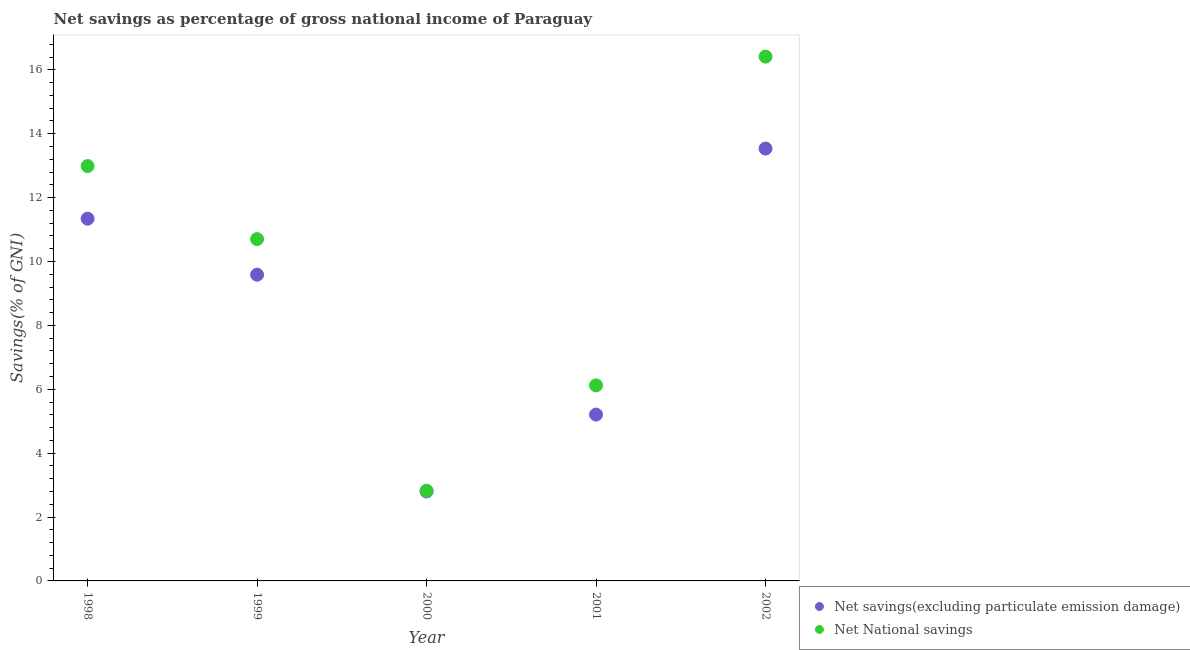How many different coloured dotlines are there?
Offer a terse response. 2. Is the number of dotlines equal to the number of legend labels?
Provide a succinct answer. Yes. What is the net national savings in 2000?
Offer a very short reply. 2.82. Across all years, what is the maximum net savings(excluding particulate emission damage)?
Your answer should be compact. 13.53. Across all years, what is the minimum net savings(excluding particulate emission damage)?
Your response must be concise. 2.8. In which year was the net national savings minimum?
Offer a very short reply. 2000. What is the total net national savings in the graph?
Make the answer very short. 49.04. What is the difference between the net national savings in 1999 and that in 2001?
Provide a short and direct response. 4.58. What is the difference between the net national savings in 1999 and the net savings(excluding particulate emission damage) in 2000?
Make the answer very short. 7.9. What is the average net savings(excluding particulate emission damage) per year?
Provide a succinct answer. 8.49. In the year 2001, what is the difference between the net national savings and net savings(excluding particulate emission damage)?
Ensure brevity in your answer.  0.91. In how many years, is the net national savings greater than 16.4 %?
Provide a succinct answer. 1. What is the ratio of the net savings(excluding particulate emission damage) in 1999 to that in 2001?
Your answer should be very brief. 1.84. What is the difference between the highest and the second highest net savings(excluding particulate emission damage)?
Your answer should be very brief. 2.19. What is the difference between the highest and the lowest net savings(excluding particulate emission damage)?
Provide a short and direct response. 10.73. In how many years, is the net savings(excluding particulate emission damage) greater than the average net savings(excluding particulate emission damage) taken over all years?
Keep it short and to the point. 3. Is the sum of the net national savings in 2000 and 2001 greater than the maximum net savings(excluding particulate emission damage) across all years?
Provide a succinct answer. No. Is the net savings(excluding particulate emission damage) strictly less than the net national savings over the years?
Your answer should be very brief. Yes. How many dotlines are there?
Offer a very short reply. 2. How many years are there in the graph?
Your answer should be very brief. 5. Does the graph contain any zero values?
Keep it short and to the point. No. How are the legend labels stacked?
Offer a terse response. Vertical. What is the title of the graph?
Provide a succinct answer. Net savings as percentage of gross national income of Paraguay. Does "Methane" appear as one of the legend labels in the graph?
Keep it short and to the point. No. What is the label or title of the Y-axis?
Your response must be concise. Savings(% of GNI). What is the Savings(% of GNI) of Net savings(excluding particulate emission damage) in 1998?
Offer a very short reply. 11.34. What is the Savings(% of GNI) of Net National savings in 1998?
Your answer should be very brief. 12.99. What is the Savings(% of GNI) of Net savings(excluding particulate emission damage) in 1999?
Your answer should be very brief. 9.59. What is the Savings(% of GNI) in Net National savings in 1999?
Keep it short and to the point. 10.7. What is the Savings(% of GNI) in Net savings(excluding particulate emission damage) in 2000?
Keep it short and to the point. 2.8. What is the Savings(% of GNI) in Net National savings in 2000?
Offer a very short reply. 2.82. What is the Savings(% of GNI) of Net savings(excluding particulate emission damage) in 2001?
Offer a terse response. 5.21. What is the Savings(% of GNI) of Net National savings in 2001?
Your answer should be very brief. 6.12. What is the Savings(% of GNI) of Net savings(excluding particulate emission damage) in 2002?
Offer a very short reply. 13.53. What is the Savings(% of GNI) of Net National savings in 2002?
Provide a succinct answer. 16.41. Across all years, what is the maximum Savings(% of GNI) of Net savings(excluding particulate emission damage)?
Keep it short and to the point. 13.53. Across all years, what is the maximum Savings(% of GNI) of Net National savings?
Provide a short and direct response. 16.41. Across all years, what is the minimum Savings(% of GNI) of Net savings(excluding particulate emission damage)?
Your response must be concise. 2.8. Across all years, what is the minimum Savings(% of GNI) in Net National savings?
Your response must be concise. 2.82. What is the total Savings(% of GNI) in Net savings(excluding particulate emission damage) in the graph?
Make the answer very short. 42.47. What is the total Savings(% of GNI) in Net National savings in the graph?
Provide a succinct answer. 49.04. What is the difference between the Savings(% of GNI) in Net savings(excluding particulate emission damage) in 1998 and that in 1999?
Your response must be concise. 1.75. What is the difference between the Savings(% of GNI) of Net National savings in 1998 and that in 1999?
Offer a terse response. 2.29. What is the difference between the Savings(% of GNI) in Net savings(excluding particulate emission damage) in 1998 and that in 2000?
Keep it short and to the point. 8.54. What is the difference between the Savings(% of GNI) of Net National savings in 1998 and that in 2000?
Ensure brevity in your answer.  10.16. What is the difference between the Savings(% of GNI) of Net savings(excluding particulate emission damage) in 1998 and that in 2001?
Offer a terse response. 6.13. What is the difference between the Savings(% of GNI) of Net National savings in 1998 and that in 2001?
Give a very brief answer. 6.87. What is the difference between the Savings(% of GNI) in Net savings(excluding particulate emission damage) in 1998 and that in 2002?
Provide a succinct answer. -2.19. What is the difference between the Savings(% of GNI) in Net National savings in 1998 and that in 2002?
Provide a short and direct response. -3.43. What is the difference between the Savings(% of GNI) of Net savings(excluding particulate emission damage) in 1999 and that in 2000?
Offer a very short reply. 6.79. What is the difference between the Savings(% of GNI) in Net National savings in 1999 and that in 2000?
Give a very brief answer. 7.88. What is the difference between the Savings(% of GNI) of Net savings(excluding particulate emission damage) in 1999 and that in 2001?
Offer a very short reply. 4.38. What is the difference between the Savings(% of GNI) in Net National savings in 1999 and that in 2001?
Your answer should be very brief. 4.58. What is the difference between the Savings(% of GNI) in Net savings(excluding particulate emission damage) in 1999 and that in 2002?
Make the answer very short. -3.95. What is the difference between the Savings(% of GNI) of Net National savings in 1999 and that in 2002?
Give a very brief answer. -5.71. What is the difference between the Savings(% of GNI) in Net savings(excluding particulate emission damage) in 2000 and that in 2001?
Provide a short and direct response. -2.41. What is the difference between the Savings(% of GNI) in Net National savings in 2000 and that in 2001?
Your answer should be compact. -3.3. What is the difference between the Savings(% of GNI) of Net savings(excluding particulate emission damage) in 2000 and that in 2002?
Provide a short and direct response. -10.73. What is the difference between the Savings(% of GNI) of Net National savings in 2000 and that in 2002?
Your answer should be compact. -13.59. What is the difference between the Savings(% of GNI) in Net savings(excluding particulate emission damage) in 2001 and that in 2002?
Keep it short and to the point. -8.33. What is the difference between the Savings(% of GNI) of Net National savings in 2001 and that in 2002?
Make the answer very short. -10.29. What is the difference between the Savings(% of GNI) of Net savings(excluding particulate emission damage) in 1998 and the Savings(% of GNI) of Net National savings in 1999?
Provide a succinct answer. 0.64. What is the difference between the Savings(% of GNI) of Net savings(excluding particulate emission damage) in 1998 and the Savings(% of GNI) of Net National savings in 2000?
Your answer should be compact. 8.52. What is the difference between the Savings(% of GNI) of Net savings(excluding particulate emission damage) in 1998 and the Savings(% of GNI) of Net National savings in 2001?
Offer a terse response. 5.22. What is the difference between the Savings(% of GNI) of Net savings(excluding particulate emission damage) in 1998 and the Savings(% of GNI) of Net National savings in 2002?
Give a very brief answer. -5.07. What is the difference between the Savings(% of GNI) of Net savings(excluding particulate emission damage) in 1999 and the Savings(% of GNI) of Net National savings in 2000?
Provide a succinct answer. 6.76. What is the difference between the Savings(% of GNI) of Net savings(excluding particulate emission damage) in 1999 and the Savings(% of GNI) of Net National savings in 2001?
Provide a succinct answer. 3.46. What is the difference between the Savings(% of GNI) in Net savings(excluding particulate emission damage) in 1999 and the Savings(% of GNI) in Net National savings in 2002?
Give a very brief answer. -6.83. What is the difference between the Savings(% of GNI) in Net savings(excluding particulate emission damage) in 2000 and the Savings(% of GNI) in Net National savings in 2001?
Offer a very short reply. -3.32. What is the difference between the Savings(% of GNI) of Net savings(excluding particulate emission damage) in 2000 and the Savings(% of GNI) of Net National savings in 2002?
Provide a short and direct response. -13.61. What is the difference between the Savings(% of GNI) of Net savings(excluding particulate emission damage) in 2001 and the Savings(% of GNI) of Net National savings in 2002?
Offer a very short reply. -11.21. What is the average Savings(% of GNI) of Net savings(excluding particulate emission damage) per year?
Offer a very short reply. 8.49. What is the average Savings(% of GNI) in Net National savings per year?
Give a very brief answer. 9.81. In the year 1998, what is the difference between the Savings(% of GNI) in Net savings(excluding particulate emission damage) and Savings(% of GNI) in Net National savings?
Offer a very short reply. -1.65. In the year 1999, what is the difference between the Savings(% of GNI) of Net savings(excluding particulate emission damage) and Savings(% of GNI) of Net National savings?
Your answer should be very brief. -1.11. In the year 2000, what is the difference between the Savings(% of GNI) of Net savings(excluding particulate emission damage) and Savings(% of GNI) of Net National savings?
Your answer should be very brief. -0.02. In the year 2001, what is the difference between the Savings(% of GNI) in Net savings(excluding particulate emission damage) and Savings(% of GNI) in Net National savings?
Your answer should be very brief. -0.91. In the year 2002, what is the difference between the Savings(% of GNI) in Net savings(excluding particulate emission damage) and Savings(% of GNI) in Net National savings?
Provide a short and direct response. -2.88. What is the ratio of the Savings(% of GNI) of Net savings(excluding particulate emission damage) in 1998 to that in 1999?
Ensure brevity in your answer.  1.18. What is the ratio of the Savings(% of GNI) in Net National savings in 1998 to that in 1999?
Offer a very short reply. 1.21. What is the ratio of the Savings(% of GNI) in Net savings(excluding particulate emission damage) in 1998 to that in 2000?
Ensure brevity in your answer.  4.05. What is the ratio of the Savings(% of GNI) of Net National savings in 1998 to that in 2000?
Your answer should be very brief. 4.6. What is the ratio of the Savings(% of GNI) in Net savings(excluding particulate emission damage) in 1998 to that in 2001?
Offer a terse response. 2.18. What is the ratio of the Savings(% of GNI) in Net National savings in 1998 to that in 2001?
Make the answer very short. 2.12. What is the ratio of the Savings(% of GNI) in Net savings(excluding particulate emission damage) in 1998 to that in 2002?
Your answer should be compact. 0.84. What is the ratio of the Savings(% of GNI) in Net National savings in 1998 to that in 2002?
Make the answer very short. 0.79. What is the ratio of the Savings(% of GNI) in Net savings(excluding particulate emission damage) in 1999 to that in 2000?
Offer a very short reply. 3.42. What is the ratio of the Savings(% of GNI) of Net National savings in 1999 to that in 2000?
Ensure brevity in your answer.  3.79. What is the ratio of the Savings(% of GNI) in Net savings(excluding particulate emission damage) in 1999 to that in 2001?
Give a very brief answer. 1.84. What is the ratio of the Savings(% of GNI) in Net National savings in 1999 to that in 2001?
Ensure brevity in your answer.  1.75. What is the ratio of the Savings(% of GNI) in Net savings(excluding particulate emission damage) in 1999 to that in 2002?
Your answer should be very brief. 0.71. What is the ratio of the Savings(% of GNI) in Net National savings in 1999 to that in 2002?
Your answer should be compact. 0.65. What is the ratio of the Savings(% of GNI) in Net savings(excluding particulate emission damage) in 2000 to that in 2001?
Provide a short and direct response. 0.54. What is the ratio of the Savings(% of GNI) in Net National savings in 2000 to that in 2001?
Ensure brevity in your answer.  0.46. What is the ratio of the Savings(% of GNI) in Net savings(excluding particulate emission damage) in 2000 to that in 2002?
Your answer should be compact. 0.21. What is the ratio of the Savings(% of GNI) in Net National savings in 2000 to that in 2002?
Ensure brevity in your answer.  0.17. What is the ratio of the Savings(% of GNI) in Net savings(excluding particulate emission damage) in 2001 to that in 2002?
Your response must be concise. 0.38. What is the ratio of the Savings(% of GNI) in Net National savings in 2001 to that in 2002?
Ensure brevity in your answer.  0.37. What is the difference between the highest and the second highest Savings(% of GNI) of Net savings(excluding particulate emission damage)?
Provide a short and direct response. 2.19. What is the difference between the highest and the second highest Savings(% of GNI) of Net National savings?
Your answer should be very brief. 3.43. What is the difference between the highest and the lowest Savings(% of GNI) in Net savings(excluding particulate emission damage)?
Offer a terse response. 10.73. What is the difference between the highest and the lowest Savings(% of GNI) in Net National savings?
Your answer should be compact. 13.59. 